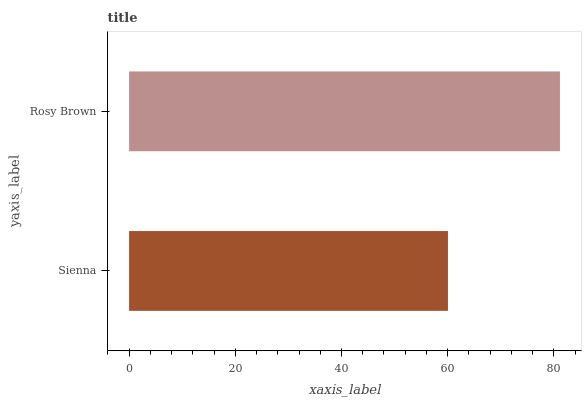Is Sienna the minimum?
Answer yes or no. Yes. Is Rosy Brown the maximum?
Answer yes or no. Yes. Is Rosy Brown the minimum?
Answer yes or no. No. Is Rosy Brown greater than Sienna?
Answer yes or no. Yes. Is Sienna less than Rosy Brown?
Answer yes or no. Yes. Is Sienna greater than Rosy Brown?
Answer yes or no. No. Is Rosy Brown less than Sienna?
Answer yes or no. No. Is Rosy Brown the high median?
Answer yes or no. Yes. Is Sienna the low median?
Answer yes or no. Yes. Is Sienna the high median?
Answer yes or no. No. Is Rosy Brown the low median?
Answer yes or no. No. 